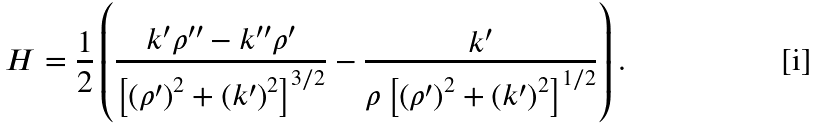Convert formula to latex. <formula><loc_0><loc_0><loc_500><loc_500>H = \frac { 1 } { 2 } \left ( \frac { k ^ { \prime } \rho ^ { \prime \prime } - k ^ { \prime \prime } \rho ^ { \prime } } { \left [ \left ( \rho ^ { \prime } \right ) ^ { 2 } + \left ( k ^ { \prime } \right ) ^ { 2 } \right ] ^ { 3 / 2 } } - \frac { k ^ { \prime } } { \rho \left [ \left ( \rho ^ { \prime } \right ) ^ { 2 } + \left ( k ^ { \prime } \right ) ^ { 2 } \right ] ^ { 1 / 2 } } \right ) .</formula> 